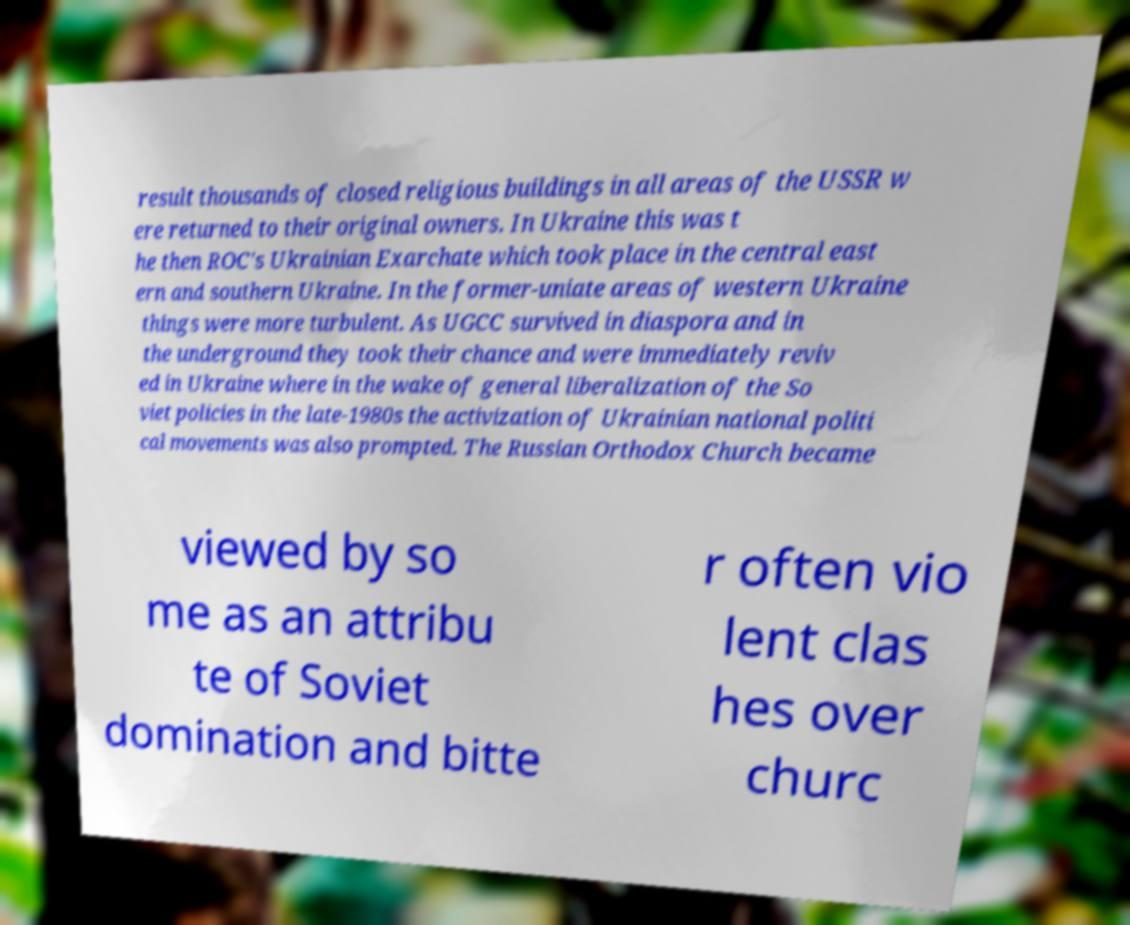What messages or text are displayed in this image? I need them in a readable, typed format. result thousands of closed religious buildings in all areas of the USSR w ere returned to their original owners. In Ukraine this was t he then ROC's Ukrainian Exarchate which took place in the central east ern and southern Ukraine. In the former-uniate areas of western Ukraine things were more turbulent. As UGCC survived in diaspora and in the underground they took their chance and were immediately reviv ed in Ukraine where in the wake of general liberalization of the So viet policies in the late-1980s the activization of Ukrainian national politi cal movements was also prompted. The Russian Orthodox Church became viewed by so me as an attribu te of Soviet domination and bitte r often vio lent clas hes over churc 